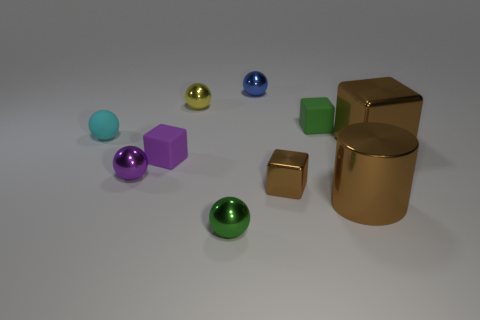Subtract all purple blocks. How many blocks are left? 3 Subtract all blue metallic balls. How many balls are left? 4 Subtract all cylinders. How many objects are left? 9 Subtract 3 cubes. How many cubes are left? 1 Subtract 0 gray balls. How many objects are left? 10 Subtract all yellow cubes. Subtract all red cylinders. How many cubes are left? 4 Subtract all red balls. How many blue cylinders are left? 0 Subtract all small metal objects. Subtract all small rubber things. How many objects are left? 2 Add 2 blue objects. How many blue objects are left? 3 Add 6 big yellow shiny cubes. How many big yellow shiny cubes exist? 6 